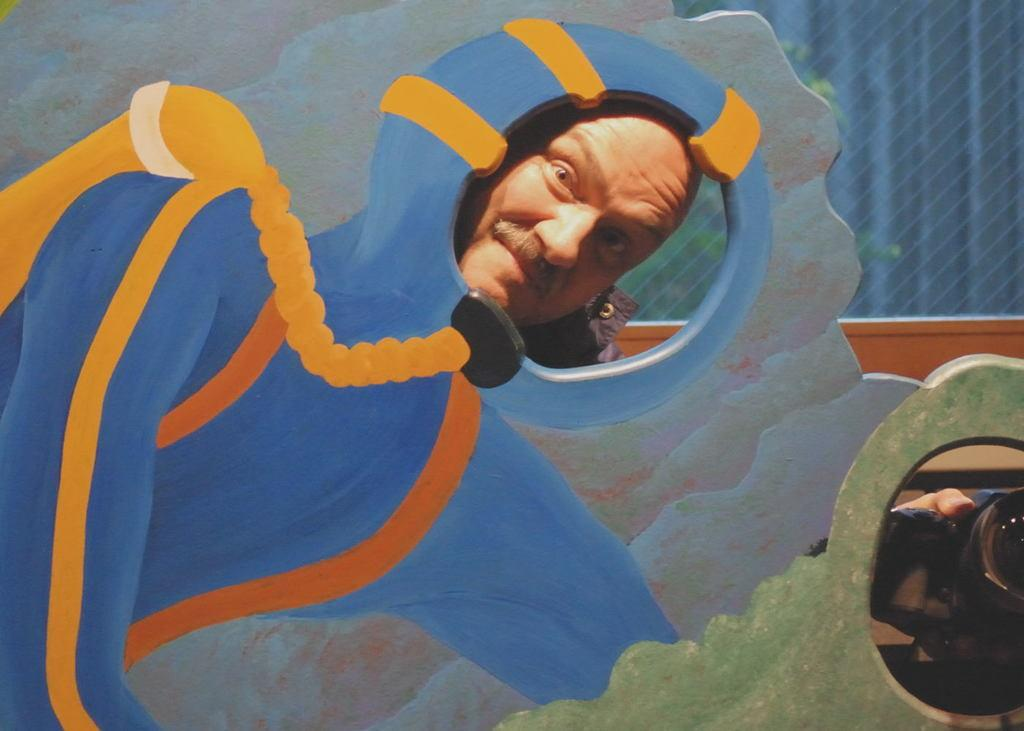What is present in the image? There is a man in the image. What is the man doing in the image? The man is giving a pose for a photo. Is the man riding a bike in the image? No, the man is not riding a bike in the image; he is giving a pose for a photo. Is the man in an office setting in the image? There is no information about the setting or location of the image, so it cannot be determined if the man is in an office. 